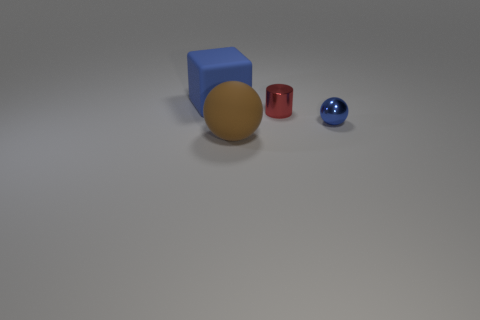What can you infer about the lighting of the scene based on the shadows of the objects? The objects cast soft-edged shadows toward the right side, suggesting a diffuse light source, likely positioned to the upper left. The shadows imply an indoor setting with controlled lighting conditions. 